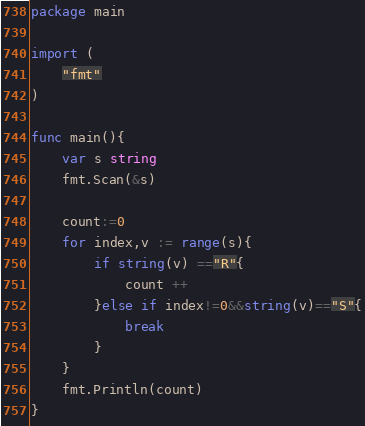<code> <loc_0><loc_0><loc_500><loc_500><_Go_>package main

import (
	"fmt"
)

func main(){
	var s string
	fmt.Scan(&s)

	count:=0
	for index,v := range(s){
		if string(v) =="R"{
			count ++
		}else if index!=0&&string(v)=="S"{
			break
		}
	}
	fmt.Println(count)
}
</code> 